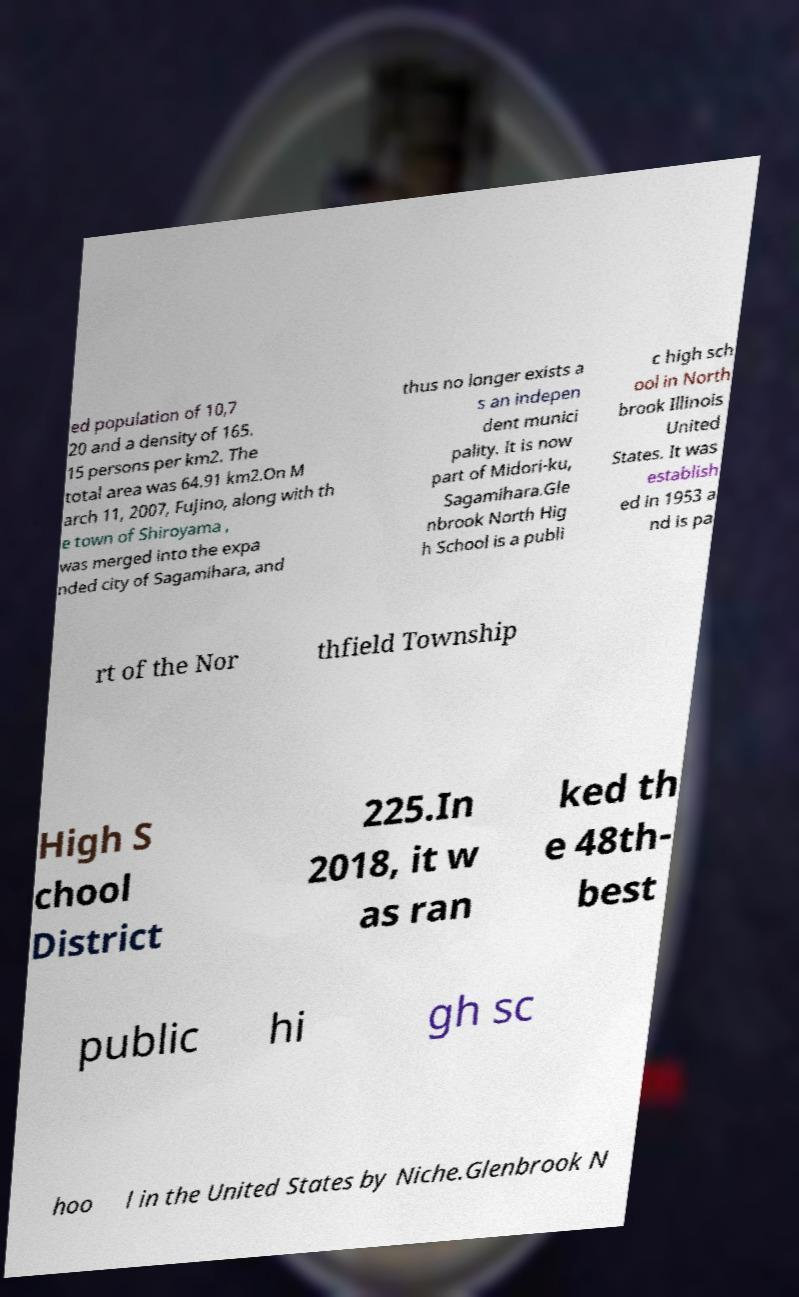I need the written content from this picture converted into text. Can you do that? ed population of 10,7 20 and a density of 165. 15 persons per km2. The total area was 64.91 km2.On M arch 11, 2007, Fujino, along with th e town of Shiroyama , was merged into the expa nded city of Sagamihara, and thus no longer exists a s an indepen dent munici pality. It is now part of Midori-ku, Sagamihara.Gle nbrook North Hig h School is a publi c high sch ool in North brook Illinois United States. It was establish ed in 1953 a nd is pa rt of the Nor thfield Township High S chool District 225.In 2018, it w as ran ked th e 48th- best public hi gh sc hoo l in the United States by Niche.Glenbrook N 